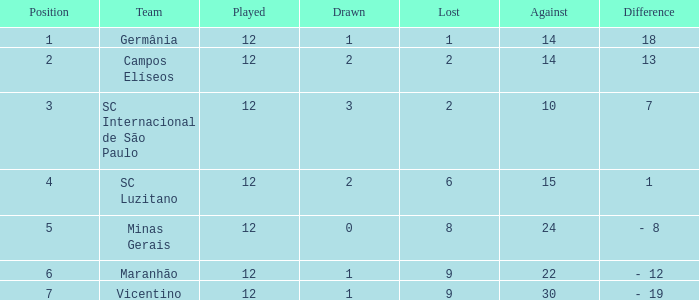What is the total of drawn games in which a player has played more than 12 times? 0.0. 